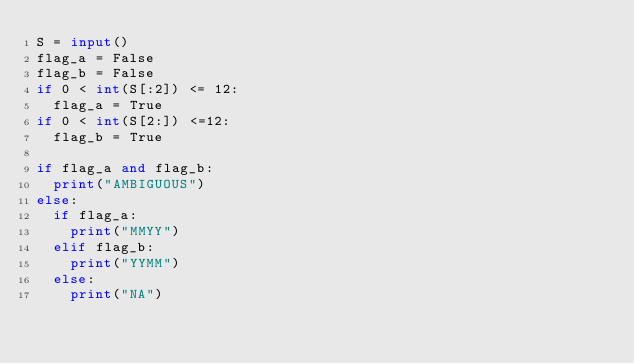<code> <loc_0><loc_0><loc_500><loc_500><_Python_>S = input()
flag_a = False
flag_b = False
if 0 < int(S[:2]) <= 12:
  flag_a = True
if 0 < int(S[2:]) <=12:
  flag_b = True
  
if flag_a and flag_b:
  print("AMBIGUOUS")
else:
  if flag_a:
    print("MMYY")
  elif flag_b:
    print("YYMM")
  else:
    print("NA")</code> 